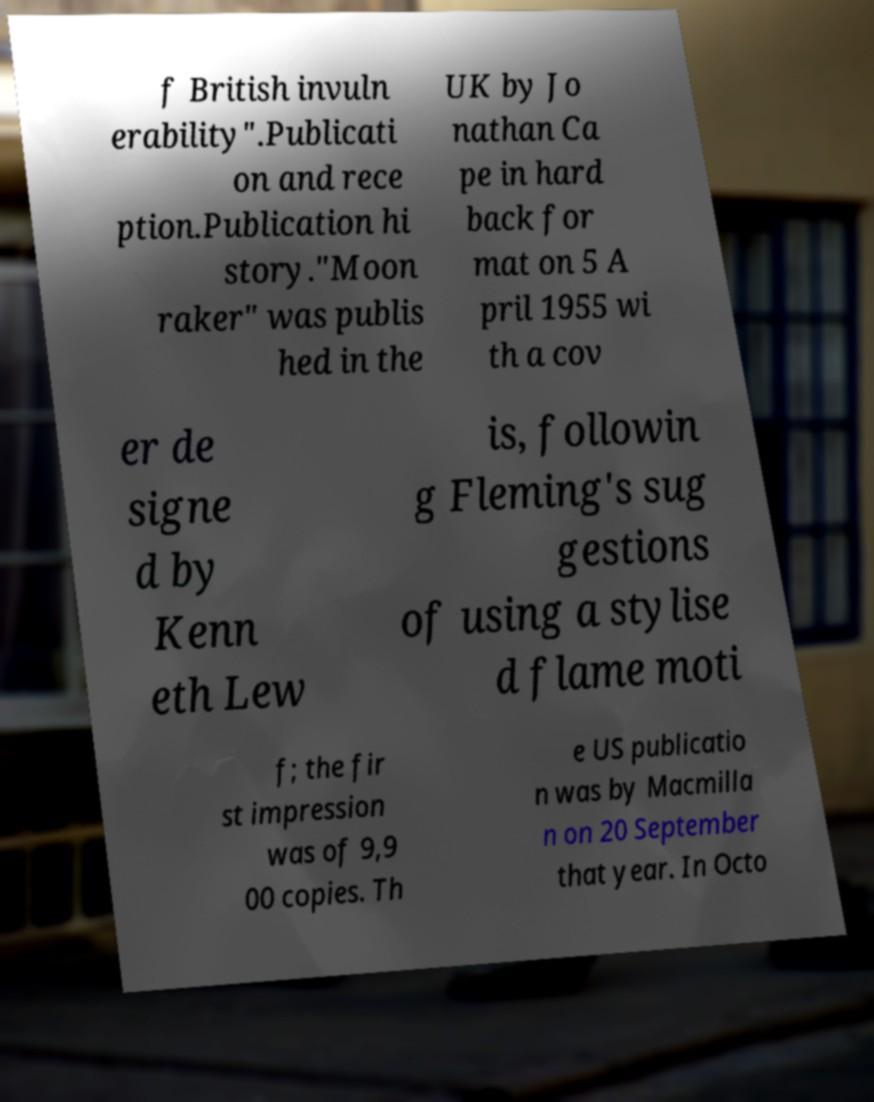What messages or text are displayed in this image? I need them in a readable, typed format. f British invuln erability".Publicati on and rece ption.Publication hi story."Moon raker" was publis hed in the UK by Jo nathan Ca pe in hard back for mat on 5 A pril 1955 wi th a cov er de signe d by Kenn eth Lew is, followin g Fleming's sug gestions of using a stylise d flame moti f; the fir st impression was of 9,9 00 copies. Th e US publicatio n was by Macmilla n on 20 September that year. In Octo 